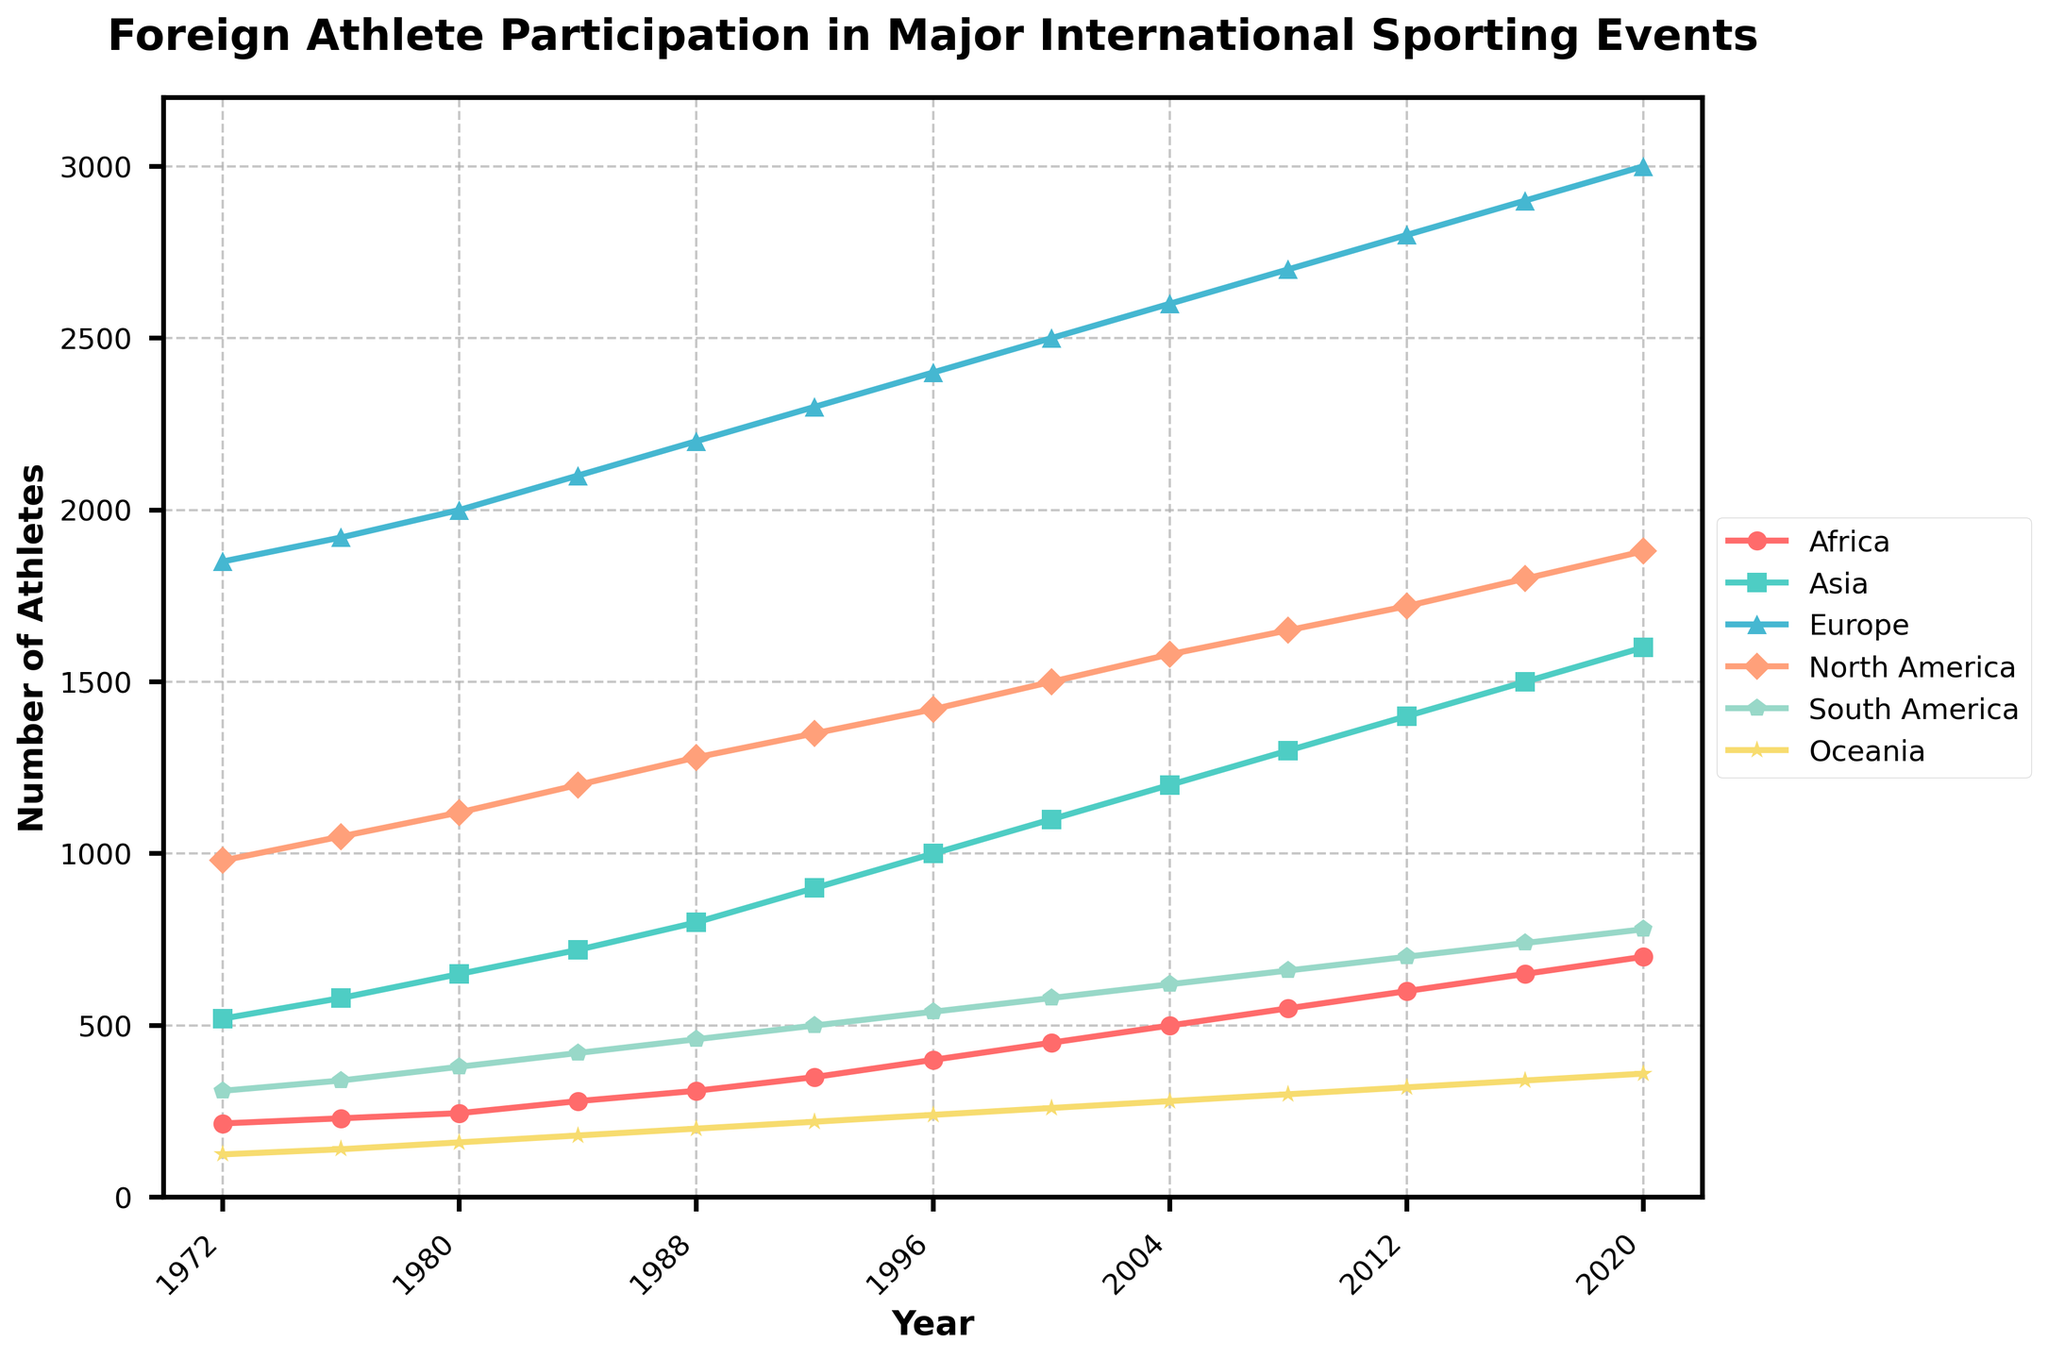How many more athletes from Europe participated in 2020 compared to 1972? The number of athletes from Europe in 1972 is 1850, and in 2020, it is 3000. To find the difference, subtract the number in 1972 from the number in 2020: 3000 - 1850 = 1150.
Answer: 1150 Which continent saw the largest increase in athlete participation from 1972 to 2020? To determine the largest increase, we need to compare the differences in athlete numbers for each continent between 2020 and 1972. The increases are:
- Africa: 700 - 215 = 485
- Asia: 1600 - 520 = 1080
- Europe: 3000 - 1850 = 1150
- North America: 1880 - 980 = 900
- South America: 780 - 310 = 470
- Oceania: 360 - 125 = 235
Europe has the largest increase.
Answer: Europe What is the average number of athletes from Asia over the given period? To find the average number of athletes from Asia, sum the numbers from each year and divide by the number of years: 
(520 + 580 + 650 + 720 + 800 + 900 + 1000 + 1100 + 1200 + 1300 + 1400 + 1500 + 1600) / 13 = 12310 / 13 ≈ 947.69.
Answer: 947.69 Which year had the smallest number of athletes from South America? By examining the data for South America, the year with the smallest number is 1972, with 310 athletes.
Answer: 1972 In what year did North America surpass 1500 athletes? From the data, North America had 1500 athletes in 2000 and then increased to 1580 in 2004. Thus, the year North America surpassed 1500 athletes is 2004.
Answer: 2004 Which continent generally shows the steepest upward trend in athlete participation? By visually assessing the slopes of the lines, Europe shows the steepest upward trend, indicating a more rapid increase in athlete participation.
Answer: Europe Compare the growth rates of athlete participation in Africa and Oceania from 1972 to 2020. Which one grew faster? Growth rate = (Value in 2020 - Value in 1972) / (2020 - 1972). 
- Africa: (700 - 215) / (2020 - 1972) = 485 / 48 ≈ 10.10
- Oceania: (360 - 125) / (2020 - 1972) = 235 / 48 ≈ 4.90
Africa grew faster.
Answer: Africa What is the difference in the number of athletes from Asia and North America in 2016? The number of athletes from Asia in 2016 is 1500, and from North America is 1800. The difference is 1800 - 1500 = 300.
Answer: 300 From which year did Oceania consistently send more than 200 athletes? Oceania had more than 200 athletes starting in 1988 with 200 athletes. Subsequent years consistently have more. Thus, 1988 is the year Oceania started consistently sending more than 200 athletes.
Answer: 1988 In which years did South America have an equal number of athletes as achieved by Asia in 1984? In 1984, Asia had 720 athletes. South America does not have any year matching that exact number; hence, they never sent exactly 720 athletes in this period.
Answer: Never 